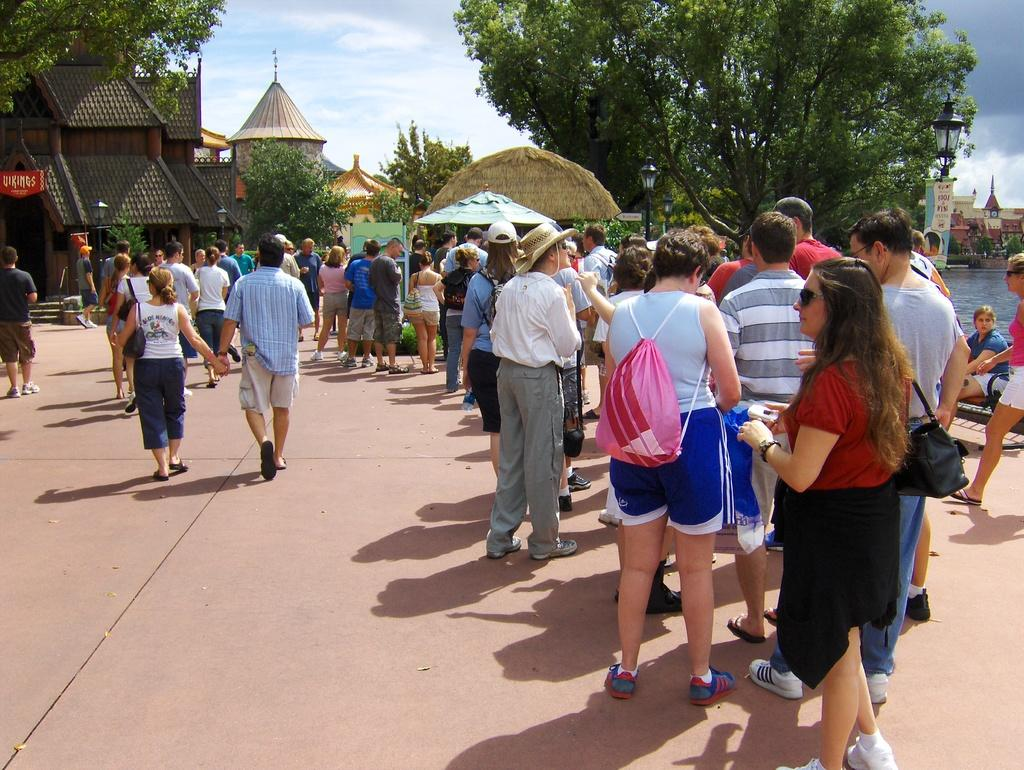What can be seen in the image? There are people standing in the image, along with houses, trees, and the sky. Can you describe the setting of the image? The image features people standing in front of houses, surrounded by trees, with the sky visible above. What type of vegetation is present in the image? Trees are present in the image. Where is the needle located in the image? There is no needle present in the image. Is there a jail visible in the image? There is no jail present in the image. 